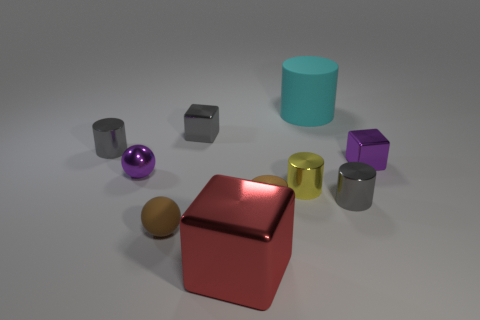What number of purple objects have the same material as the small purple cube?
Ensure brevity in your answer.  1. Does the purple thing left of the cyan matte thing have the same material as the small brown sphere?
Make the answer very short. No. Are there any small purple things?
Keep it short and to the point. Yes. There is a thing that is in front of the brown metallic cylinder and right of the brown rubber thing; what is its size?
Your response must be concise. Large. Are there more matte things that are behind the big red thing than small balls in front of the small yellow cylinder?
Your answer should be compact. Yes. The thing that is the same color as the shiny ball is what size?
Keep it short and to the point. Small. What is the color of the tiny rubber object?
Your answer should be very brief. Brown. What color is the object that is both in front of the yellow thing and on the left side of the red thing?
Make the answer very short. Brown. There is a small sphere behind the gray cylinder that is right of the tiny cylinder behind the purple shiny cube; what is its color?
Offer a terse response. Purple. There is a metallic ball that is the same size as the matte ball; what color is it?
Ensure brevity in your answer.  Purple. 